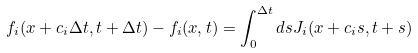Convert formula to latex. <formula><loc_0><loc_0><loc_500><loc_500>f _ { i } ( { x } + { c } _ { i } \Delta t , t + \Delta t ) - f _ { i } ( { x } , t ) = \int _ { 0 } ^ { \Delta t } d s J _ { i } ( { x } + { c } _ { i } s , t + s )</formula> 